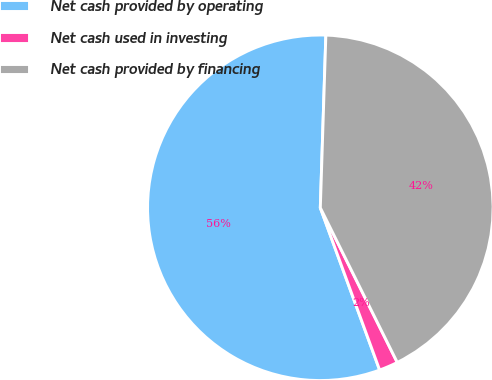Convert chart. <chart><loc_0><loc_0><loc_500><loc_500><pie_chart><fcel>Net cash provided by operating<fcel>Net cash used in investing<fcel>Net cash provided by financing<nl><fcel>56.09%<fcel>1.77%<fcel>42.14%<nl></chart> 